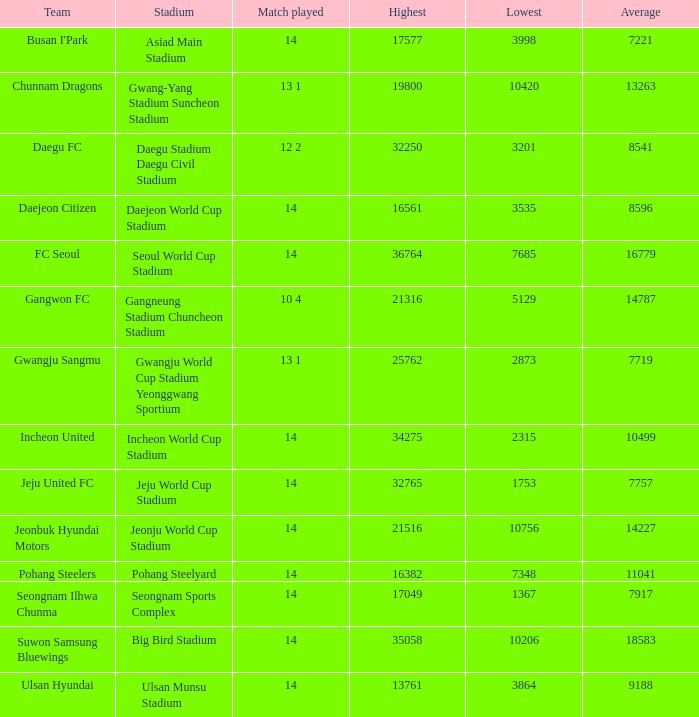How many match played have the highest as 32250? 12 2. 